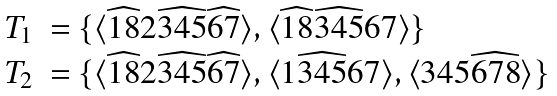<formula> <loc_0><loc_0><loc_500><loc_500>\begin{array} { r l } T _ { 1 } & = \{ \langle \widehat { 1 8 } 2 \widehat { 3 4 5 } \widehat { 6 7 } \rangle , \langle \widehat { 1 8 } \widehat { 3 4 5 } 6 7 \rangle \} \\ T _ { 2 } & = \{ \langle \widehat { 1 8 } 2 \widehat { 3 4 5 } \widehat { 6 7 } \rangle , \langle 1 \widehat { 3 4 5 } 6 7 \rangle , \langle 3 4 5 \widehat { 6 7 8 } \rangle \} \end{array}</formula> 